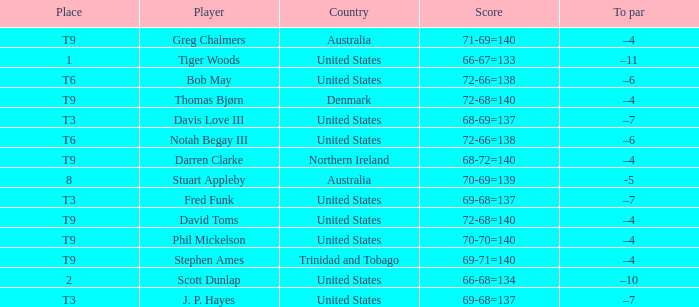What is the To par value that goes with a Score of 70-69=139? -5.0. 